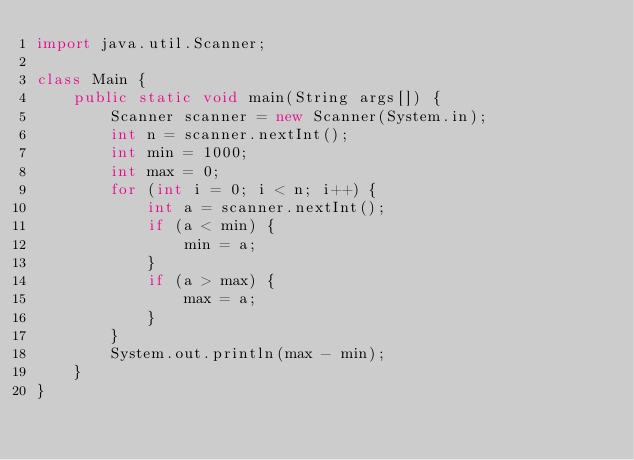<code> <loc_0><loc_0><loc_500><loc_500><_Java_>import java.util.Scanner;

class Main {
    public static void main(String args[]) {
        Scanner scanner = new Scanner(System.in);
        int n = scanner.nextInt();
        int min = 1000;
        int max = 0;
        for (int i = 0; i < n; i++) {
            int a = scanner.nextInt();
            if (a < min) {
                min = a;
            }
            if (a > max) {
                max = a;
            }
        }
        System.out.println(max - min);
    }
}
</code> 